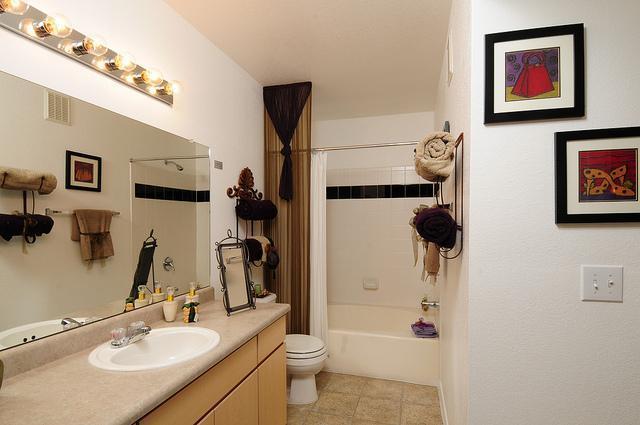How many paintings are there?
Give a very brief answer. 3. How many cars are the same color as the fire hydrant?
Give a very brief answer. 0. 